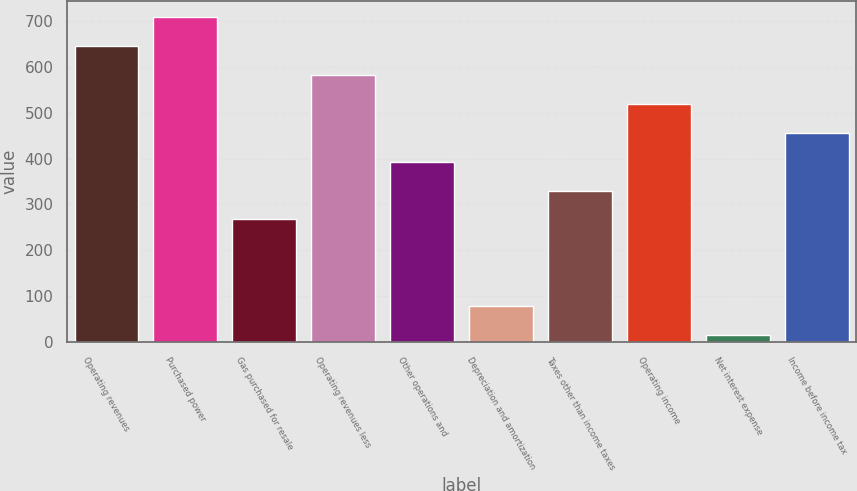<chart> <loc_0><loc_0><loc_500><loc_500><bar_chart><fcel>Operating revenues<fcel>Purchased power<fcel>Gas purchased for resale<fcel>Operating revenues less<fcel>Other operations and<fcel>Depreciation and amortization<fcel>Taxes other than income taxes<fcel>Operating income<fcel>Net interest expense<fcel>Income before income tax<nl><fcel>646<fcel>709.1<fcel>267.4<fcel>582.9<fcel>393.6<fcel>78.1<fcel>330.5<fcel>519.8<fcel>15<fcel>456.7<nl></chart> 